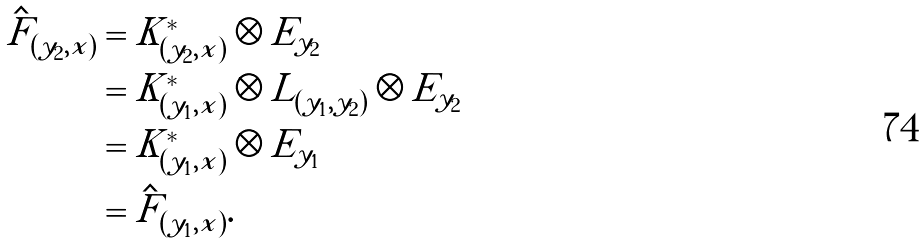Convert formula to latex. <formula><loc_0><loc_0><loc_500><loc_500>\hat { F } _ { ( y _ { 2 } , x ) } & = K _ { ( y _ { 2 } , x ) } ^ { * } \otimes E _ { y _ { 2 } } \\ & = K _ { ( y _ { 1 } , x ) } ^ { * } \otimes L _ { ( y _ { 1 } , y _ { 2 } ) } \otimes E _ { y _ { 2 } } \\ & = K _ { ( y _ { 1 } , x ) } ^ { * } \otimes E _ { y _ { 1 } } \\ & = \hat { F } _ { ( y _ { 1 } , x ) } .</formula> 